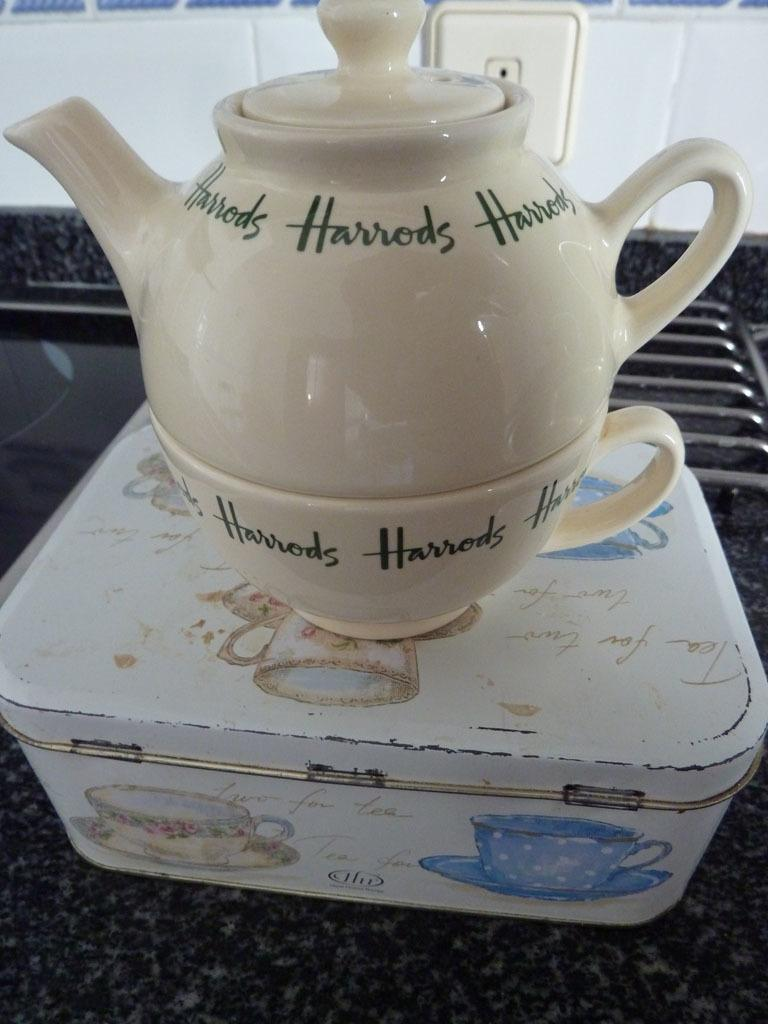What is the main object in the image? There is a teapot in the image. What other object is related to the teapot? There is a cup in the image. What is located at the bottom of the image? There is a box at the bottom of the image. What can be seen in the background of the image? Tiles are visible in the background of the image. What architectural feature is present on the right side of the image? There are grilles on the right side of the image. How does the teapot hate the pump in the image? There is no pump present in the image, and therefore no such interaction can be observed. 